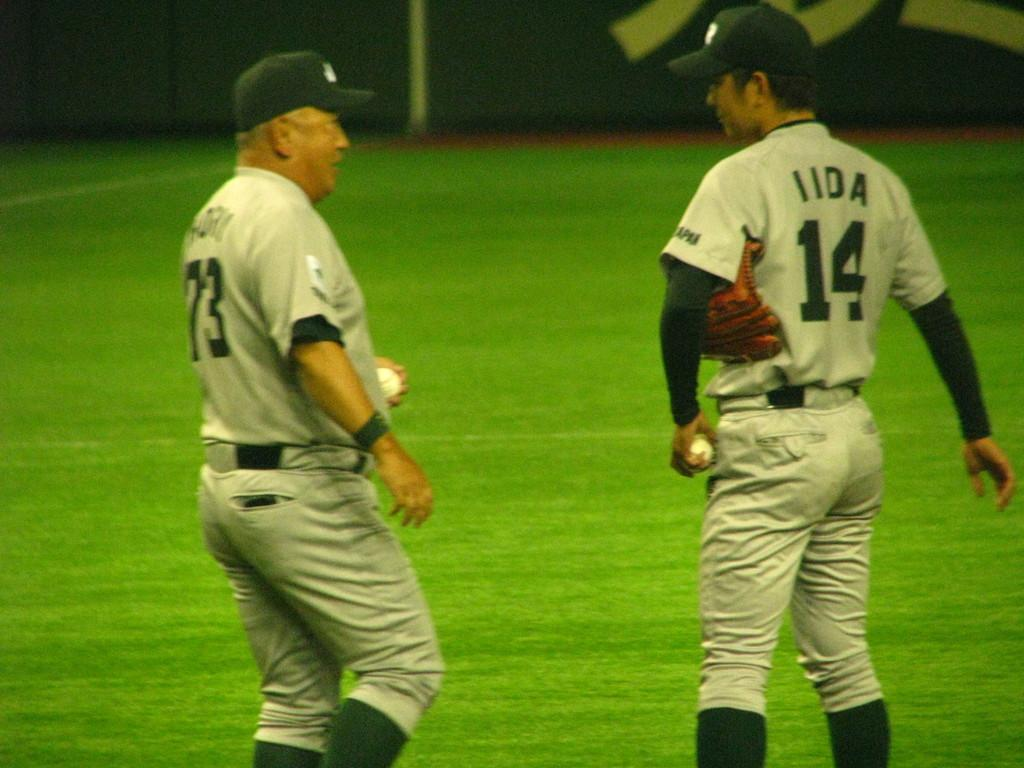<image>
Provide a brief description of the given image. Player number 14 speaks to man with number 73. 